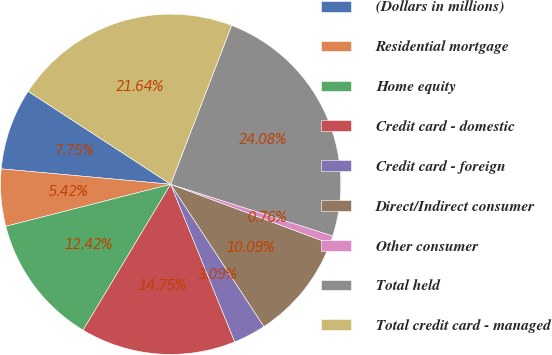<chart> <loc_0><loc_0><loc_500><loc_500><pie_chart><fcel>(Dollars in millions)<fcel>Residential mortgage<fcel>Home equity<fcel>Credit card - domestic<fcel>Credit card - foreign<fcel>Direct/Indirect consumer<fcel>Other consumer<fcel>Total held<fcel>Total credit card - managed<nl><fcel>7.75%<fcel>5.42%<fcel>12.42%<fcel>14.75%<fcel>3.09%<fcel>10.09%<fcel>0.76%<fcel>24.08%<fcel>21.64%<nl></chart> 